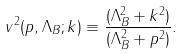Convert formula to latex. <formula><loc_0><loc_0><loc_500><loc_500>v ^ { 2 } ( p , \Lambda _ { B } ; k ) \equiv \frac { ( \Lambda _ { B } ^ { 2 } + k ^ { 2 } ) } { ( \Lambda _ { B } ^ { 2 } + p ^ { 2 } ) } .</formula> 